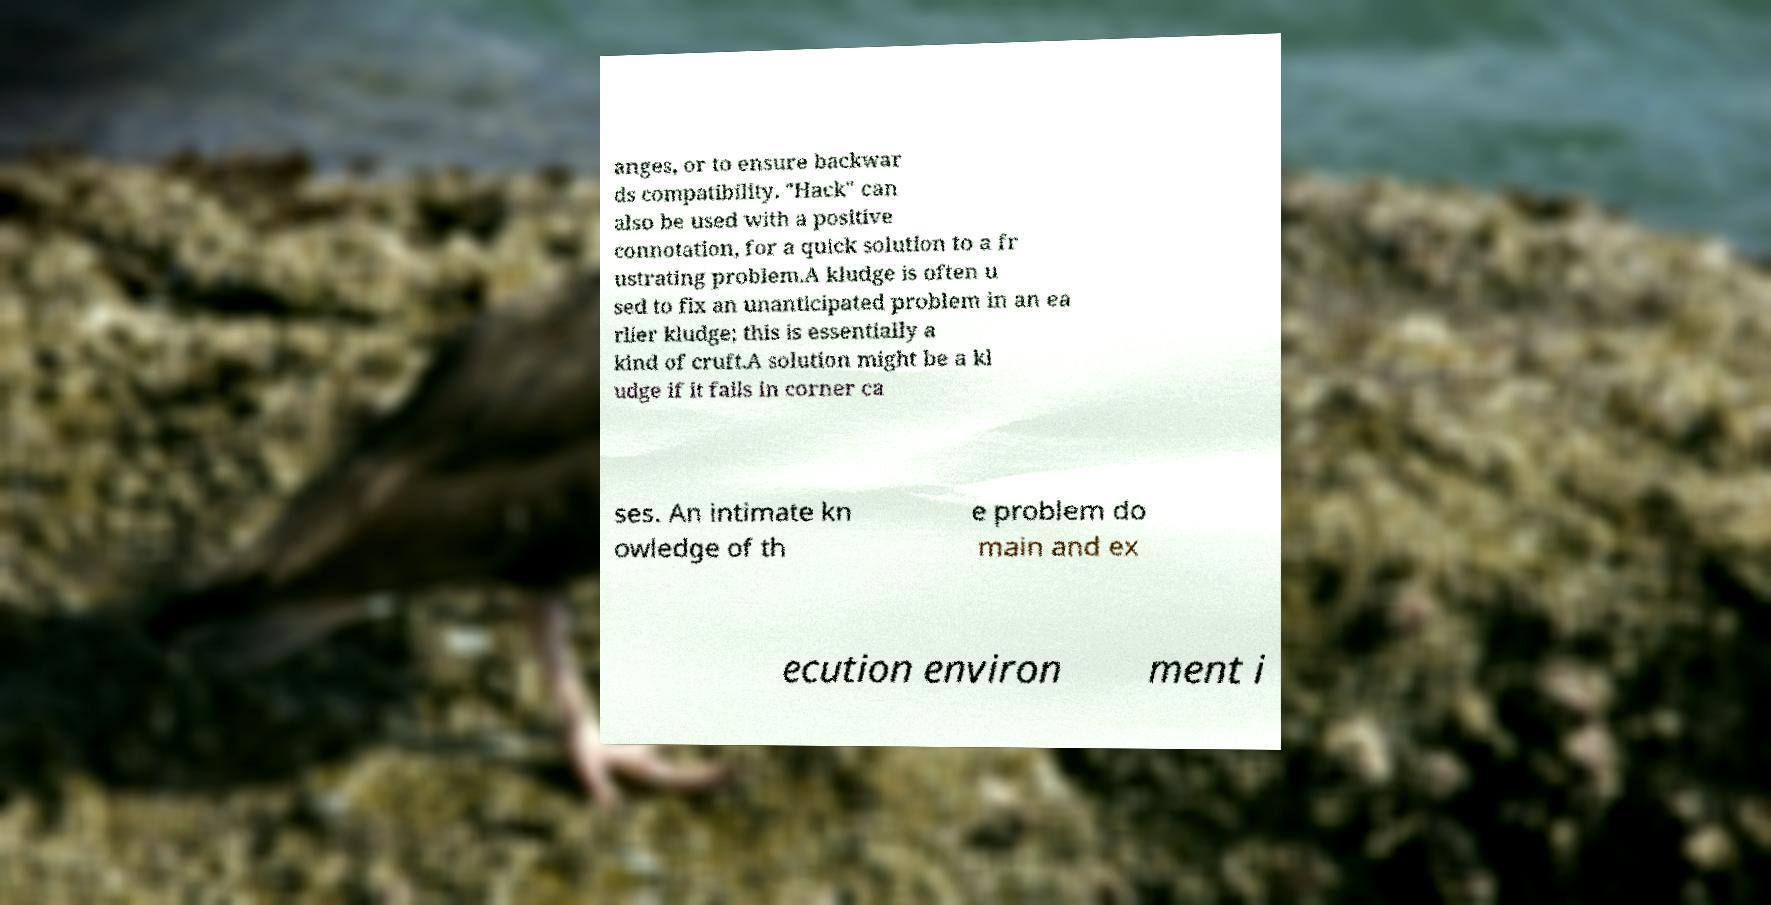Please read and relay the text visible in this image. What does it say? anges, or to ensure backwar ds compatibility. "Hack" can also be used with a positive connotation, for a quick solution to a fr ustrating problem.A kludge is often u sed to fix an unanticipated problem in an ea rlier kludge; this is essentially a kind of cruft.A solution might be a kl udge if it fails in corner ca ses. An intimate kn owledge of th e problem do main and ex ecution environ ment i 